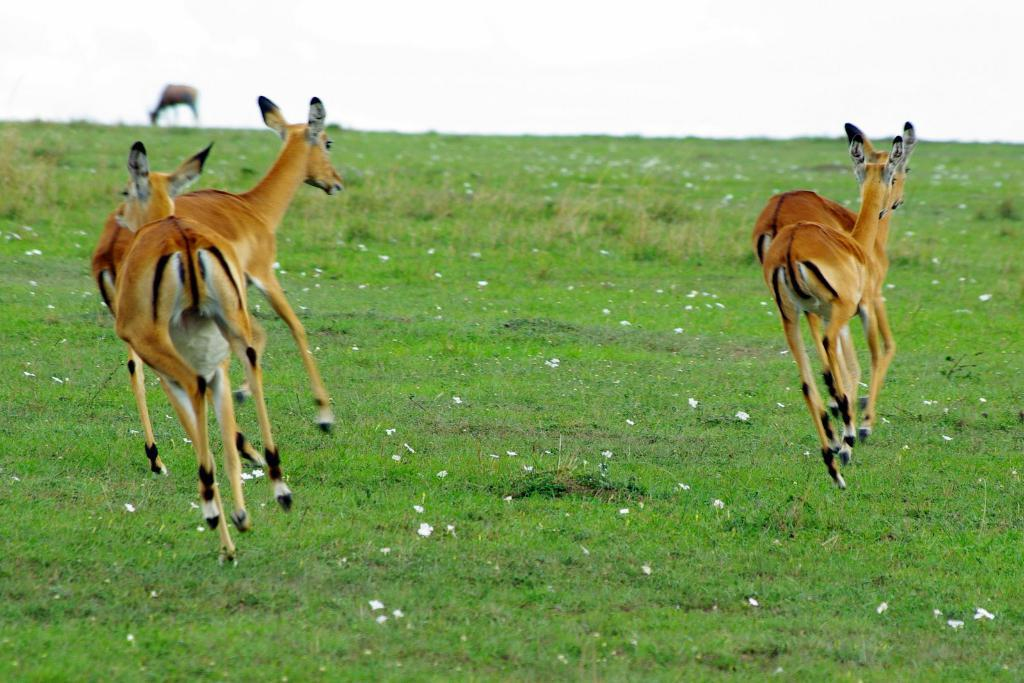What type of animals can be seen in the image? There are deer in the image. What type of vegetation is present in the image? There is grass in the image. What type of flowers can be seen in the image? There are white flowers in the image. What is the color of the sky in the image? The sky is white in the image. What type of corn can be seen growing in the image? There is no corn present in the image. How can the white flowers be used in the image? The image does not show the flowers being used for any specific purpose. 